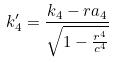<formula> <loc_0><loc_0><loc_500><loc_500>k _ { 4 } ^ { \prime } = \frac { k _ { 4 } - r a _ { 4 } } { \sqrt { 1 - \frac { r ^ { 4 } } { c ^ { 4 } } } }</formula> 